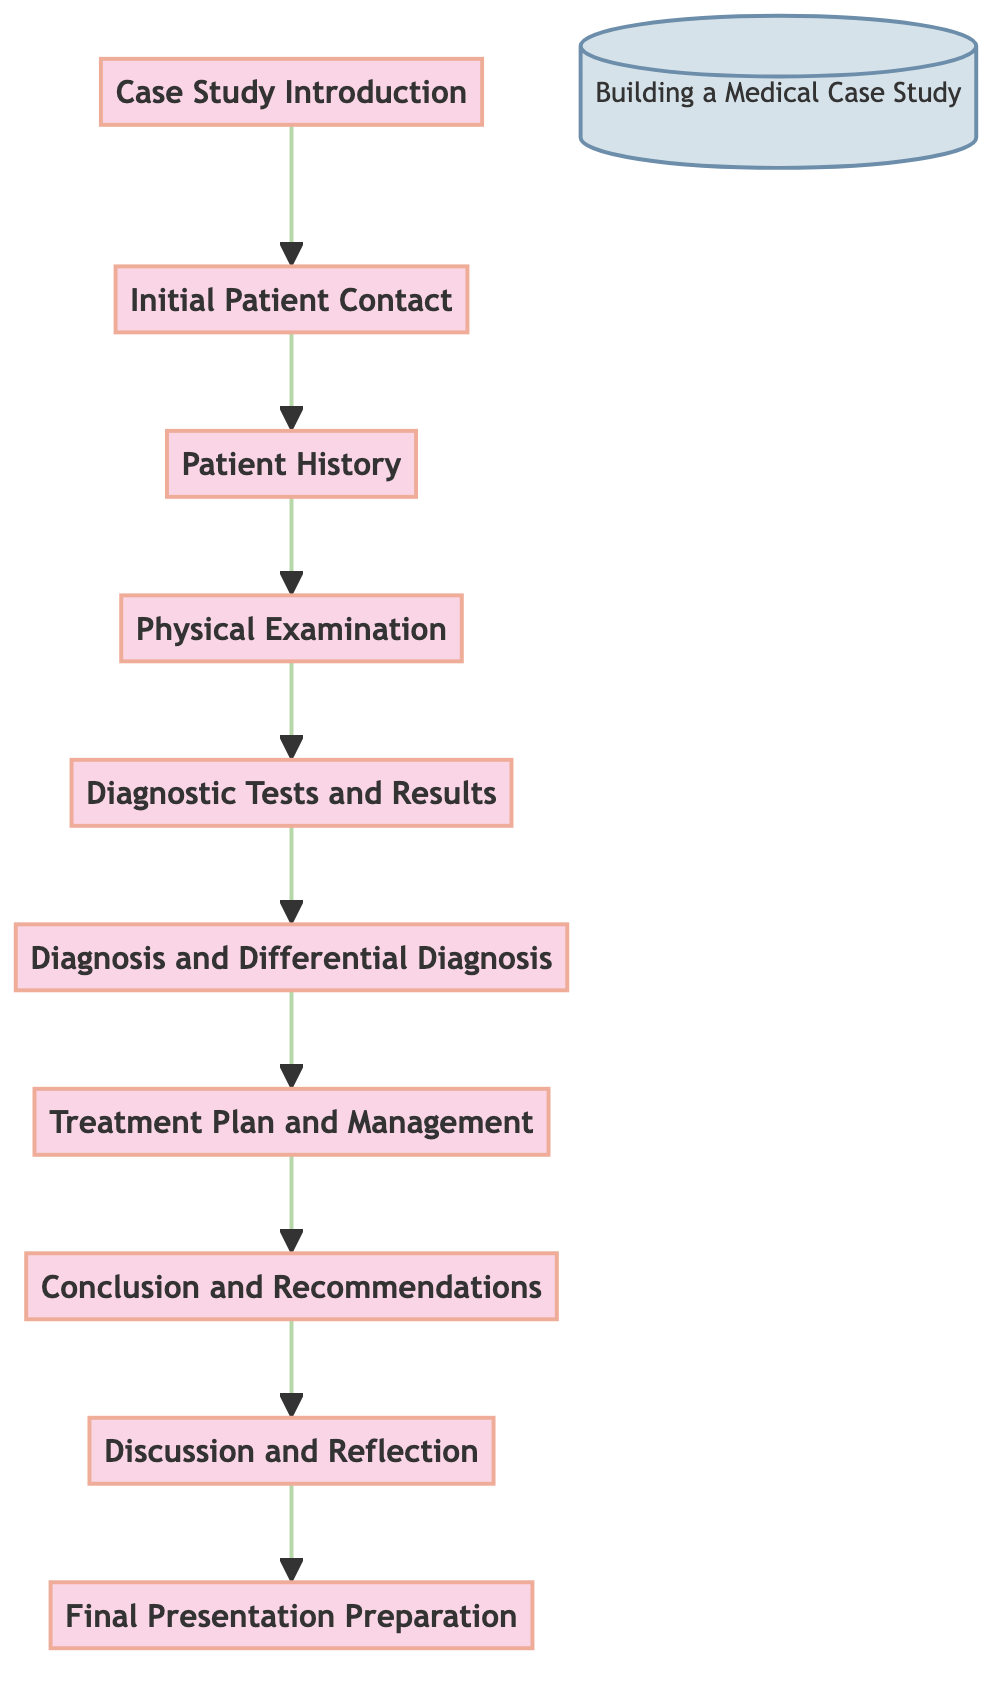What is the first step in building a medical case study? The first step in the diagram is labeled as "Case Study Introduction." This is the starting point that introduces the context and objectives for the case study.
Answer: Case Study Introduction How many total steps are involved in the case study process? The diagram lists ten distinct steps ranging from "Case Study Introduction" to "Final Presentation Preparation." By counting each step, we find there are ten total steps.
Answer: 10 What step comes immediately after "Patient History"? The diagram shows an arrow from "Patient History" pointing to "Physical Examination." This tells us that "Physical Examination" is the next sequential step after "Patient History."
Answer: Physical Examination What is the last step of the process? The final step in the flow chart is labeled "Final Presentation Preparation." This is the last action to take after traversing through the earlier steps.
Answer: Final Presentation Preparation What is discussed in the step following "Conclusion and Recommendations"? The flow chart indicates that after "Conclusion and Recommendations," there is "Discussion and Reflection." Thus, this is the step where feedback and reflections happen.
Answer: Discussion and Reflection Which step involves interpreting diagnostic tests? The diagram shows that "Diagnostic Tests and Results" is the step where results from lab tests and other diagnostics are reviewed and interpreted. This step is essential for diagnosis and treatment planning.
Answer: Diagnostic Tests and Results What is a key activity in the "Treatment Plan and Management" step? In this step, the focus is on detailing the treatment plan, including medications and strategies for follow-up. Thus, this step emphasizes management strategies for the patient.
Answer: Detail the treatment plan How does the flow of the diagram progress from "Diagnosis and Differential Diagnosis"? The arrow from "Diagnosis and Differential Diagnosis" points directly to "Treatment Plan and Management," indicating that once a diagnosis is established, the subsequent focus is on planning the treatment.
Answer: Treatment Plan and Management What step immediately precedes the "Final Presentation Preparation"? According to the flow, "Discussion and Reflection" is the step that occurs right before "Final Presentation Preparation." This provides an opportunity to discuss and reflect before preparing the final presentation.
Answer: Discussion and Reflection 